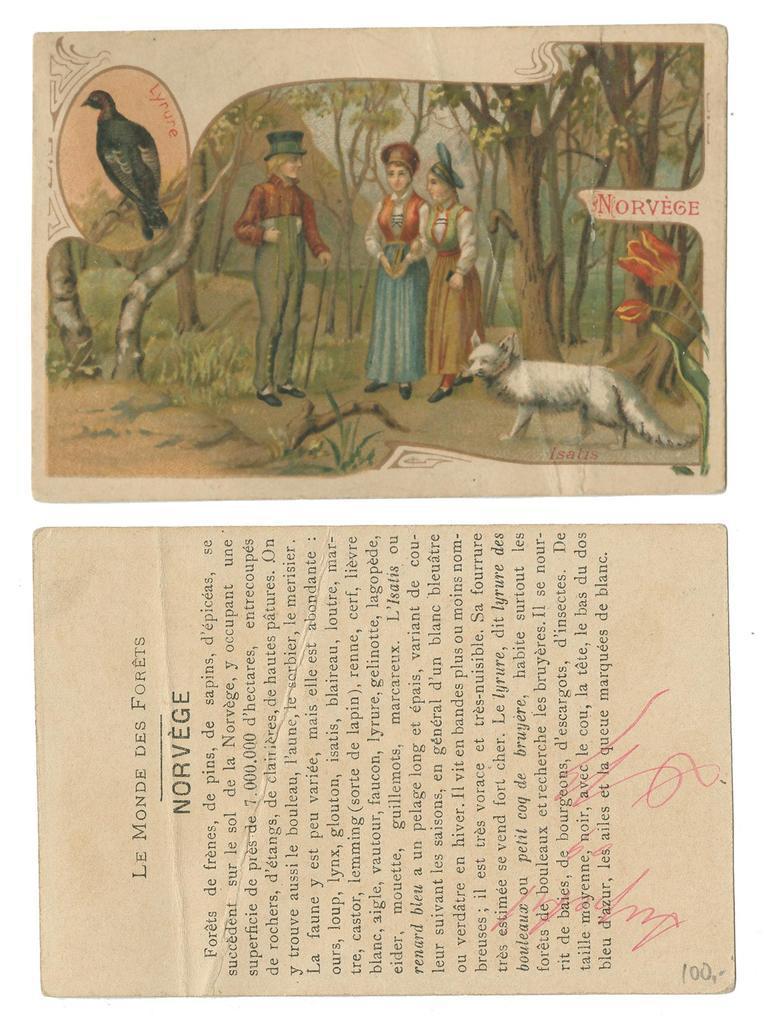In one or two sentences, can you explain what this image depicts? In this image there are two papers, where there are page numbers, photo , signatures and paragraphs on the papers. 